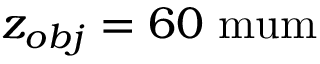<formula> <loc_0><loc_0><loc_500><loc_500>z _ { o b j } = 6 0 \ m u m</formula> 